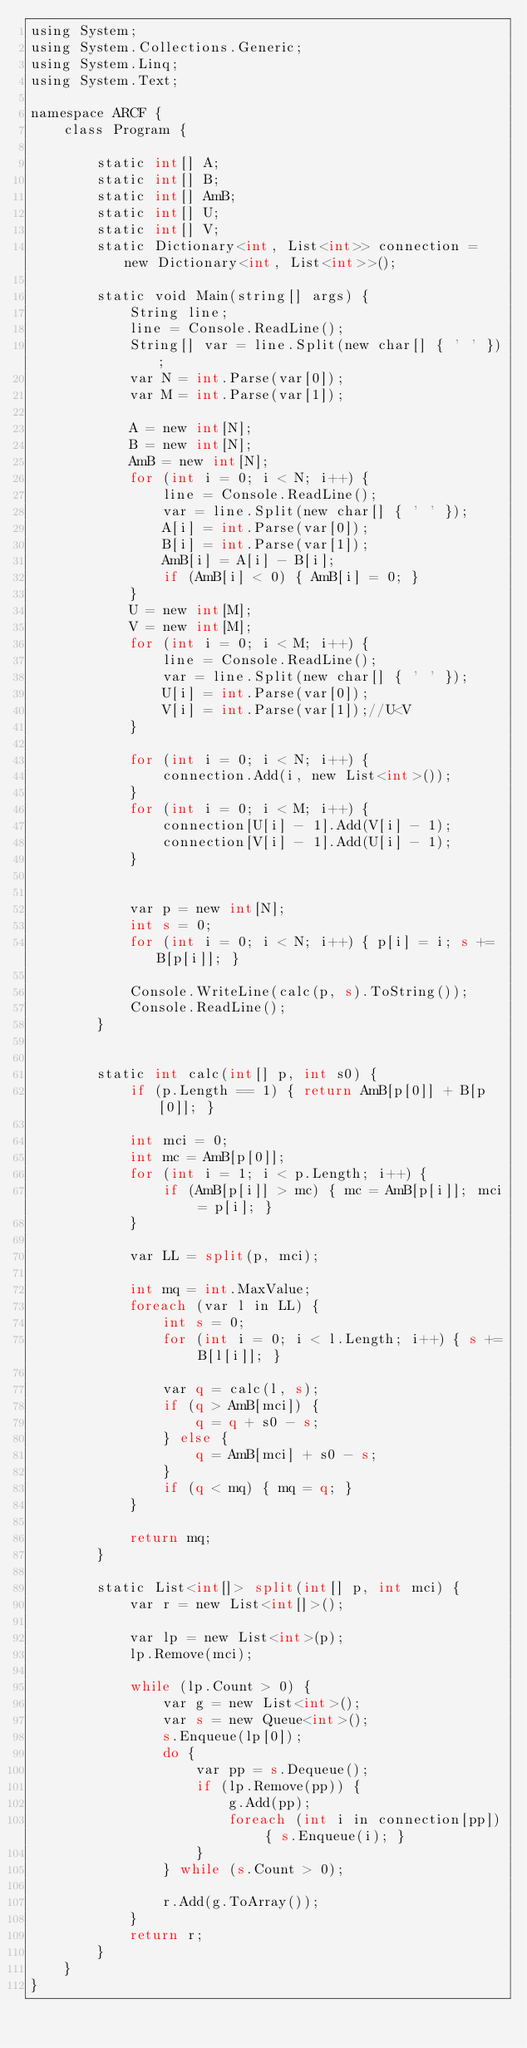Convert code to text. <code><loc_0><loc_0><loc_500><loc_500><_Perl_>using System;
using System.Collections.Generic;
using System.Linq;
using System.Text;

namespace ARCF {
    class Program {

        static int[] A;
        static int[] B;
        static int[] AmB;
        static int[] U;
        static int[] V;
        static Dictionary<int, List<int>> connection = new Dictionary<int, List<int>>();

        static void Main(string[] args) {
            String line;
            line = Console.ReadLine();
            String[] var = line.Split(new char[] { ' ' });
            var N = int.Parse(var[0]);
            var M = int.Parse(var[1]);

            A = new int[N];
            B = new int[N];
            AmB = new int[N];
            for (int i = 0; i < N; i++) {
                line = Console.ReadLine();
                var = line.Split(new char[] { ' ' });
                A[i] = int.Parse(var[0]);
                B[i] = int.Parse(var[1]);
                AmB[i] = A[i] - B[i];
                if (AmB[i] < 0) { AmB[i] = 0; }
            }
            U = new int[M];
            V = new int[M];
            for (int i = 0; i < M; i++) {
                line = Console.ReadLine();
                var = line.Split(new char[] { ' ' });
                U[i] = int.Parse(var[0]);
                V[i] = int.Parse(var[1]);//U<V
            }

            for (int i = 0; i < N; i++) {
                connection.Add(i, new List<int>());
            }
            for (int i = 0; i < M; i++) {
                connection[U[i] - 1].Add(V[i] - 1);
                connection[V[i] - 1].Add(U[i] - 1);
            }


            var p = new int[N];
            int s = 0;
            for (int i = 0; i < N; i++) { p[i] = i; s += B[p[i]]; }

            Console.WriteLine(calc(p, s).ToString());
            Console.ReadLine();
        }


        static int calc(int[] p, int s0) {
            if (p.Length == 1) { return AmB[p[0]] + B[p[0]]; }

            int mci = 0;
            int mc = AmB[p[0]];
            for (int i = 1; i < p.Length; i++) {
                if (AmB[p[i]] > mc) { mc = AmB[p[i]]; mci = p[i]; }
            }

            var LL = split(p, mci);

            int mq = int.MaxValue;
            foreach (var l in LL) {
                int s = 0;
                for (int i = 0; i < l.Length; i++) { s += B[l[i]]; }

                var q = calc(l, s);
                if (q > AmB[mci]) {
                    q = q + s0 - s;
                } else {
                    q = AmB[mci] + s0 - s;
                }
                if (q < mq) { mq = q; }
            }

            return mq;
        }

        static List<int[]> split(int[] p, int mci) {
            var r = new List<int[]>();

            var lp = new List<int>(p);
            lp.Remove(mci);

            while (lp.Count > 0) {
                var g = new List<int>();
                var s = new Queue<int>();
                s.Enqueue(lp[0]);
                do {
                    var pp = s.Dequeue();
                    if (lp.Remove(pp)) {
                        g.Add(pp);
                        foreach (int i in connection[pp]) { s.Enqueue(i); }
                    }
                } while (s.Count > 0);

                r.Add(g.ToArray());
            }
            return r;
        }
    }
}
</code> 